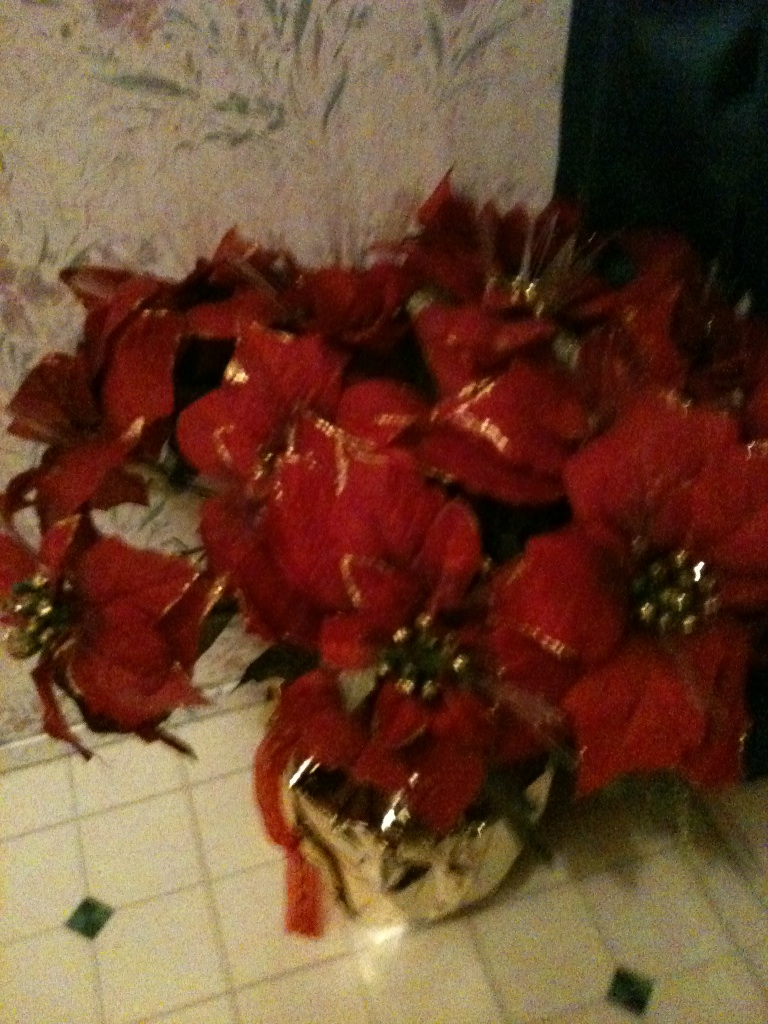Imagine if these flowers came to life, what story would they tell? If these flowers came to life, they would tell a magical tale of how they light up the world every holiday season. Each poinsettia would share stories of the families they've adorned, the festive dinners they've witnessed, and the joyous moments they've silently celebrated. In the hushed whispers of the night, they would reminisce about the warmth of houses they’ve been part of and the sparkle in children's eyes they’ve seen as part of the grand holiday tradition. They would also talk about their journey from tropical lands, overcoming challenges to bloom in places far and wide, spreading love and cheer. What might these flowers symbolize if they were part of a holiday myth? In a holiday myth, poinsettia flowers could symbolize the spirit of giving and renewal. Legend could say that long ago, a humble child gifted these vibrant blooms to a wise elder during winter solstice, symbolizing hope in the darkest of times. The red petals might represent the warmth and love of community, while the gold would signify prosperity and joy. Every winter, the return of the poinsettias could remind people to come together, share their blessings, and renew their spirits for the year ahead. 